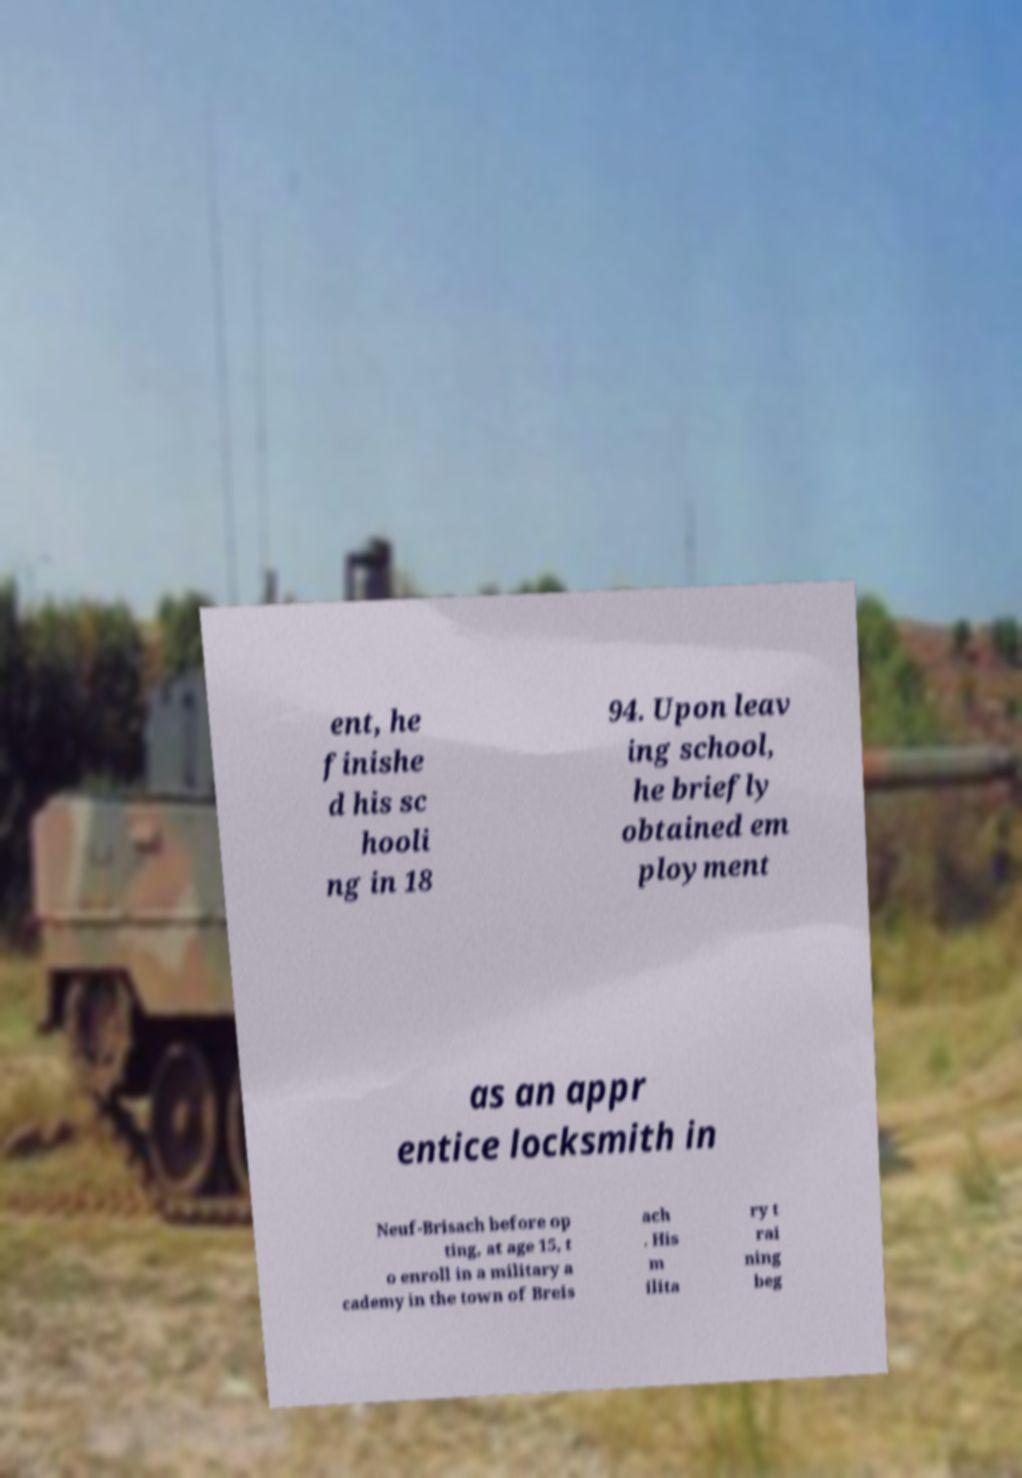Can you accurately transcribe the text from the provided image for me? ent, he finishe d his sc hooli ng in 18 94. Upon leav ing school, he briefly obtained em ployment as an appr entice locksmith in Neuf-Brisach before op ting, at age 15, t o enroll in a military a cademy in the town of Breis ach . His m ilita ry t rai ning beg 